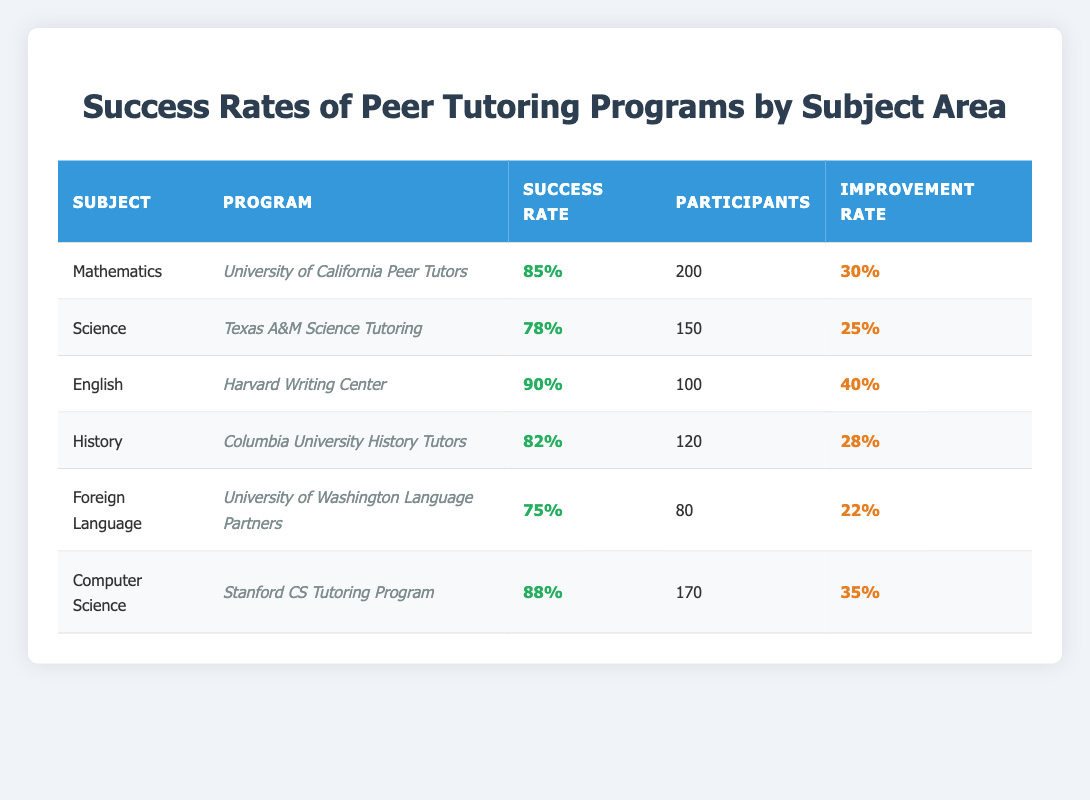What is the success rate for the English peer tutoring program? The success rate for the English peer tutoring program provided by the Harvard Writing Center is 90%. This can be found directly in the table under the "Success Rate" column for the "English" row.
Answer: 90% Which subject area has the highest participation in peer tutoring programs? The subject area with the highest participation is Mathematics, which has 200 participants as listed in the corresponding row in the table.
Answer: Mathematics What is the average improvement rate across all peer tutoring programs? To calculate the average improvement rate, we add the improvement rates for each subject: (30 + 25 + 40 + 28 + 22 + 35) = 210. Then, we divide this total by the number of subjects, which is 6, resulting in an average improvement rate of 210/6 = 35.
Answer: 35 Is the success rate of the Foreign Language tutoring program higher than that of the Science tutoring program? The success rate for the Foreign Language program is 75%, while the success rate for the Science program is 78%. Since 75 is less than 78, the answer is no.
Answer: No What is the success rate difference between the Computer Science and History peer tutoring programs? The success rate for the Computer Science program is 88%, and for History, it is 82%. To find the difference, we subtract the History success rate from the Computer Science success rate: 88 - 82 = 6.
Answer: 6 Which program shows the highest improvement rate and what is that rate? The highest improvement rate is from the English tutoring program at the Harvard Writing Center, which is 40%. This information can be found by comparing the improvement rates listed for all programs in the table.
Answer: 40 Are there more participants in the Mathematics program than in the Foreign Language program? The Mathematics program has 200 participants, while the Foreign Language program has 80 participants. Since 200 is greater than 80, the answer is yes.
Answer: Yes How many total participants are involved in peer tutoring programs for History and Science combined? For History, there are 120 participants, and for Science, there are 150 participants. To find the combined total, we add both amounts: 120 + 150 = 270.
Answer: 270 